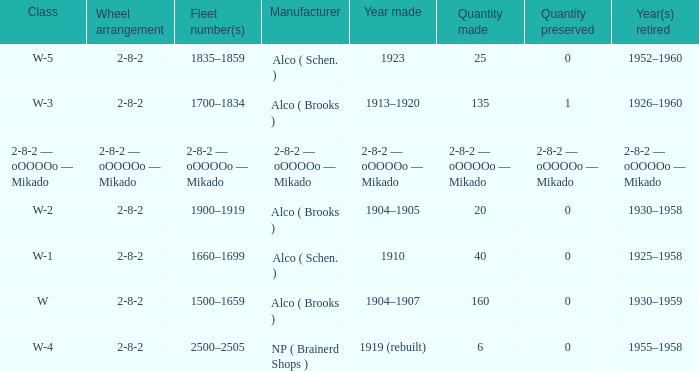When did the locomotive, of which 25 were made, retire? 1952–1960. 